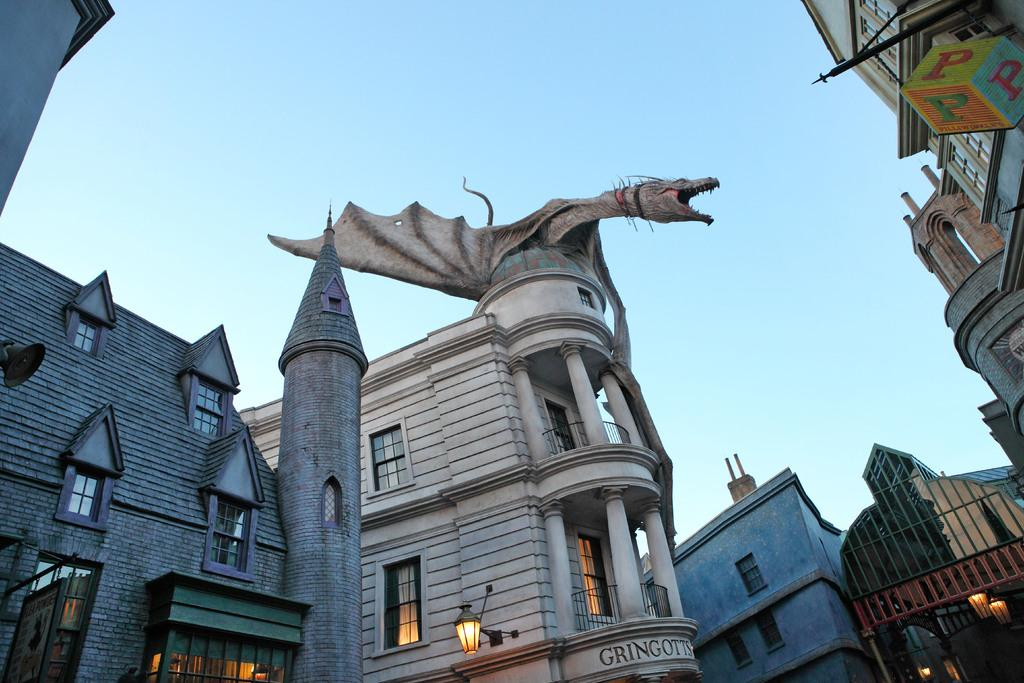What type of structures can be seen in the image? There are buildings in the image. What can be found on the right side of the image? There are objects on the right side of the image. Can you describe a specific feature of one of the buildings? There is: There is an animal statue on one of the buildings. What can be seen illuminated in the image? There are lights visible in the image. What part of the natural environment is visible in the image? The sky is visible in the image. What is the girl's opinion about the surprise in the image? There is no girl or surprise present in the image. 